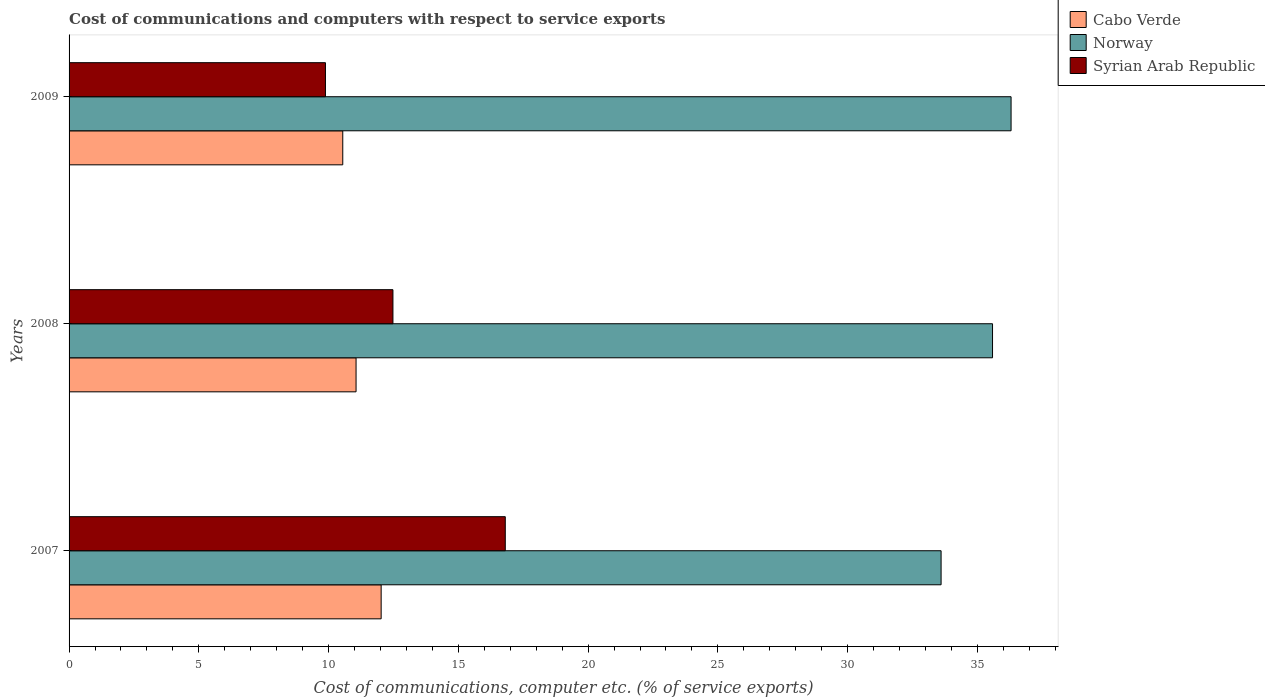How many bars are there on the 3rd tick from the top?
Provide a succinct answer. 3. What is the label of the 3rd group of bars from the top?
Make the answer very short. 2007. What is the cost of communications and computers in Cabo Verde in 2008?
Provide a succinct answer. 11.06. Across all years, what is the maximum cost of communications and computers in Syrian Arab Republic?
Make the answer very short. 16.81. Across all years, what is the minimum cost of communications and computers in Norway?
Offer a terse response. 33.6. What is the total cost of communications and computers in Syrian Arab Republic in the graph?
Provide a succinct answer. 39.17. What is the difference between the cost of communications and computers in Norway in 2007 and that in 2009?
Provide a short and direct response. -2.7. What is the difference between the cost of communications and computers in Cabo Verde in 2009 and the cost of communications and computers in Norway in 2008?
Your answer should be compact. -25.04. What is the average cost of communications and computers in Cabo Verde per year?
Your answer should be compact. 11.21. In the year 2008, what is the difference between the cost of communications and computers in Norway and cost of communications and computers in Syrian Arab Republic?
Your answer should be very brief. 23.1. What is the ratio of the cost of communications and computers in Syrian Arab Republic in 2008 to that in 2009?
Your answer should be very brief. 1.26. Is the cost of communications and computers in Syrian Arab Republic in 2007 less than that in 2008?
Provide a short and direct response. No. Is the difference between the cost of communications and computers in Norway in 2007 and 2008 greater than the difference between the cost of communications and computers in Syrian Arab Republic in 2007 and 2008?
Give a very brief answer. No. What is the difference between the highest and the second highest cost of communications and computers in Norway?
Provide a succinct answer. 0.71. What is the difference between the highest and the lowest cost of communications and computers in Cabo Verde?
Your answer should be very brief. 1.48. In how many years, is the cost of communications and computers in Norway greater than the average cost of communications and computers in Norway taken over all years?
Keep it short and to the point. 2. What does the 1st bar from the top in 2008 represents?
Ensure brevity in your answer.  Syrian Arab Republic. What does the 1st bar from the bottom in 2009 represents?
Your answer should be very brief. Cabo Verde. How many bars are there?
Offer a terse response. 9. What is the difference between two consecutive major ticks on the X-axis?
Your response must be concise. 5. Where does the legend appear in the graph?
Make the answer very short. Top right. How many legend labels are there?
Your response must be concise. 3. How are the legend labels stacked?
Keep it short and to the point. Vertical. What is the title of the graph?
Your response must be concise. Cost of communications and computers with respect to service exports. Does "Guam" appear as one of the legend labels in the graph?
Make the answer very short. No. What is the label or title of the X-axis?
Offer a very short reply. Cost of communications, computer etc. (% of service exports). What is the label or title of the Y-axis?
Keep it short and to the point. Years. What is the Cost of communications, computer etc. (% of service exports) in Cabo Verde in 2007?
Provide a succinct answer. 12.02. What is the Cost of communications, computer etc. (% of service exports) of Norway in 2007?
Offer a terse response. 33.6. What is the Cost of communications, computer etc. (% of service exports) of Syrian Arab Republic in 2007?
Provide a short and direct response. 16.81. What is the Cost of communications, computer etc. (% of service exports) of Cabo Verde in 2008?
Your answer should be compact. 11.06. What is the Cost of communications, computer etc. (% of service exports) of Norway in 2008?
Keep it short and to the point. 35.58. What is the Cost of communications, computer etc. (% of service exports) of Syrian Arab Republic in 2008?
Ensure brevity in your answer.  12.48. What is the Cost of communications, computer etc. (% of service exports) in Cabo Verde in 2009?
Ensure brevity in your answer.  10.55. What is the Cost of communications, computer etc. (% of service exports) of Norway in 2009?
Your answer should be very brief. 36.3. What is the Cost of communications, computer etc. (% of service exports) in Syrian Arab Republic in 2009?
Ensure brevity in your answer.  9.88. Across all years, what is the maximum Cost of communications, computer etc. (% of service exports) in Cabo Verde?
Your response must be concise. 12.02. Across all years, what is the maximum Cost of communications, computer etc. (% of service exports) of Norway?
Keep it short and to the point. 36.3. Across all years, what is the maximum Cost of communications, computer etc. (% of service exports) in Syrian Arab Republic?
Your answer should be very brief. 16.81. Across all years, what is the minimum Cost of communications, computer etc. (% of service exports) in Cabo Verde?
Ensure brevity in your answer.  10.55. Across all years, what is the minimum Cost of communications, computer etc. (% of service exports) in Norway?
Your response must be concise. 33.6. Across all years, what is the minimum Cost of communications, computer etc. (% of service exports) of Syrian Arab Republic?
Your response must be concise. 9.88. What is the total Cost of communications, computer etc. (% of service exports) of Cabo Verde in the graph?
Provide a succinct answer. 33.63. What is the total Cost of communications, computer etc. (% of service exports) of Norway in the graph?
Your answer should be very brief. 105.48. What is the total Cost of communications, computer etc. (% of service exports) in Syrian Arab Republic in the graph?
Your answer should be compact. 39.17. What is the difference between the Cost of communications, computer etc. (% of service exports) of Norway in 2007 and that in 2008?
Your response must be concise. -1.98. What is the difference between the Cost of communications, computer etc. (% of service exports) in Syrian Arab Republic in 2007 and that in 2008?
Keep it short and to the point. 4.33. What is the difference between the Cost of communications, computer etc. (% of service exports) of Cabo Verde in 2007 and that in 2009?
Keep it short and to the point. 1.48. What is the difference between the Cost of communications, computer etc. (% of service exports) of Norway in 2007 and that in 2009?
Your answer should be very brief. -2.7. What is the difference between the Cost of communications, computer etc. (% of service exports) of Syrian Arab Republic in 2007 and that in 2009?
Make the answer very short. 6.93. What is the difference between the Cost of communications, computer etc. (% of service exports) in Cabo Verde in 2008 and that in 2009?
Your response must be concise. 0.51. What is the difference between the Cost of communications, computer etc. (% of service exports) in Norway in 2008 and that in 2009?
Make the answer very short. -0.71. What is the difference between the Cost of communications, computer etc. (% of service exports) of Syrian Arab Republic in 2008 and that in 2009?
Make the answer very short. 2.6. What is the difference between the Cost of communications, computer etc. (% of service exports) of Cabo Verde in 2007 and the Cost of communications, computer etc. (% of service exports) of Norway in 2008?
Offer a terse response. -23.56. What is the difference between the Cost of communications, computer etc. (% of service exports) in Cabo Verde in 2007 and the Cost of communications, computer etc. (% of service exports) in Syrian Arab Republic in 2008?
Offer a terse response. -0.45. What is the difference between the Cost of communications, computer etc. (% of service exports) in Norway in 2007 and the Cost of communications, computer etc. (% of service exports) in Syrian Arab Republic in 2008?
Make the answer very short. 21.12. What is the difference between the Cost of communications, computer etc. (% of service exports) of Cabo Verde in 2007 and the Cost of communications, computer etc. (% of service exports) of Norway in 2009?
Provide a succinct answer. -24.27. What is the difference between the Cost of communications, computer etc. (% of service exports) in Cabo Verde in 2007 and the Cost of communications, computer etc. (% of service exports) in Syrian Arab Republic in 2009?
Your response must be concise. 2.15. What is the difference between the Cost of communications, computer etc. (% of service exports) in Norway in 2007 and the Cost of communications, computer etc. (% of service exports) in Syrian Arab Republic in 2009?
Your answer should be compact. 23.72. What is the difference between the Cost of communications, computer etc. (% of service exports) of Cabo Verde in 2008 and the Cost of communications, computer etc. (% of service exports) of Norway in 2009?
Offer a terse response. -25.24. What is the difference between the Cost of communications, computer etc. (% of service exports) in Cabo Verde in 2008 and the Cost of communications, computer etc. (% of service exports) in Syrian Arab Republic in 2009?
Your answer should be very brief. 1.18. What is the difference between the Cost of communications, computer etc. (% of service exports) of Norway in 2008 and the Cost of communications, computer etc. (% of service exports) of Syrian Arab Republic in 2009?
Make the answer very short. 25.7. What is the average Cost of communications, computer etc. (% of service exports) of Cabo Verde per year?
Offer a very short reply. 11.21. What is the average Cost of communications, computer etc. (% of service exports) of Norway per year?
Keep it short and to the point. 35.16. What is the average Cost of communications, computer etc. (% of service exports) in Syrian Arab Republic per year?
Make the answer very short. 13.06. In the year 2007, what is the difference between the Cost of communications, computer etc. (% of service exports) in Cabo Verde and Cost of communications, computer etc. (% of service exports) in Norway?
Keep it short and to the point. -21.58. In the year 2007, what is the difference between the Cost of communications, computer etc. (% of service exports) in Cabo Verde and Cost of communications, computer etc. (% of service exports) in Syrian Arab Republic?
Ensure brevity in your answer.  -4.78. In the year 2007, what is the difference between the Cost of communications, computer etc. (% of service exports) in Norway and Cost of communications, computer etc. (% of service exports) in Syrian Arab Republic?
Offer a very short reply. 16.79. In the year 2008, what is the difference between the Cost of communications, computer etc. (% of service exports) in Cabo Verde and Cost of communications, computer etc. (% of service exports) in Norway?
Provide a short and direct response. -24.52. In the year 2008, what is the difference between the Cost of communications, computer etc. (% of service exports) in Cabo Verde and Cost of communications, computer etc. (% of service exports) in Syrian Arab Republic?
Your answer should be very brief. -1.42. In the year 2008, what is the difference between the Cost of communications, computer etc. (% of service exports) in Norway and Cost of communications, computer etc. (% of service exports) in Syrian Arab Republic?
Your answer should be very brief. 23.1. In the year 2009, what is the difference between the Cost of communications, computer etc. (% of service exports) of Cabo Verde and Cost of communications, computer etc. (% of service exports) of Norway?
Provide a succinct answer. -25.75. In the year 2009, what is the difference between the Cost of communications, computer etc. (% of service exports) in Cabo Verde and Cost of communications, computer etc. (% of service exports) in Syrian Arab Republic?
Your answer should be very brief. 0.67. In the year 2009, what is the difference between the Cost of communications, computer etc. (% of service exports) in Norway and Cost of communications, computer etc. (% of service exports) in Syrian Arab Republic?
Offer a very short reply. 26.42. What is the ratio of the Cost of communications, computer etc. (% of service exports) of Cabo Verde in 2007 to that in 2008?
Provide a succinct answer. 1.09. What is the ratio of the Cost of communications, computer etc. (% of service exports) of Norway in 2007 to that in 2008?
Your answer should be compact. 0.94. What is the ratio of the Cost of communications, computer etc. (% of service exports) of Syrian Arab Republic in 2007 to that in 2008?
Ensure brevity in your answer.  1.35. What is the ratio of the Cost of communications, computer etc. (% of service exports) of Cabo Verde in 2007 to that in 2009?
Provide a short and direct response. 1.14. What is the ratio of the Cost of communications, computer etc. (% of service exports) of Norway in 2007 to that in 2009?
Make the answer very short. 0.93. What is the ratio of the Cost of communications, computer etc. (% of service exports) in Syrian Arab Republic in 2007 to that in 2009?
Provide a short and direct response. 1.7. What is the ratio of the Cost of communications, computer etc. (% of service exports) in Cabo Verde in 2008 to that in 2009?
Give a very brief answer. 1.05. What is the ratio of the Cost of communications, computer etc. (% of service exports) of Norway in 2008 to that in 2009?
Ensure brevity in your answer.  0.98. What is the ratio of the Cost of communications, computer etc. (% of service exports) in Syrian Arab Republic in 2008 to that in 2009?
Ensure brevity in your answer.  1.26. What is the difference between the highest and the second highest Cost of communications, computer etc. (% of service exports) in Norway?
Provide a succinct answer. 0.71. What is the difference between the highest and the second highest Cost of communications, computer etc. (% of service exports) in Syrian Arab Republic?
Provide a short and direct response. 4.33. What is the difference between the highest and the lowest Cost of communications, computer etc. (% of service exports) of Cabo Verde?
Your answer should be very brief. 1.48. What is the difference between the highest and the lowest Cost of communications, computer etc. (% of service exports) of Norway?
Give a very brief answer. 2.7. What is the difference between the highest and the lowest Cost of communications, computer etc. (% of service exports) of Syrian Arab Republic?
Offer a very short reply. 6.93. 